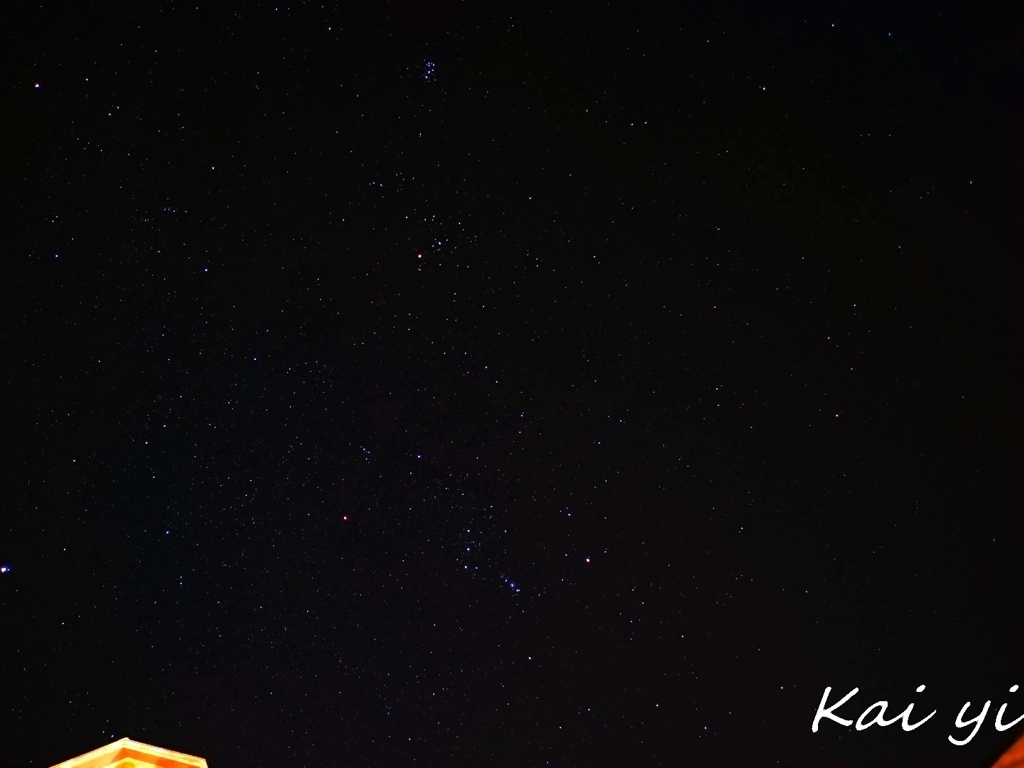Does the image showcase details and textures in night sky photography? The image does capture elements of the night sky, including numerous stars and possibly constellations, which is indicative of typical night sky photography. However, details such as the Milky Way, nebulae, or other deep sky objects aren't clearly visible, which might be due to light pollution, exposure settings or camera capabilities. When aiming for detailed night sky photography, such as astrophotography, one would expect to see more defined textures and celestial phenomena. 